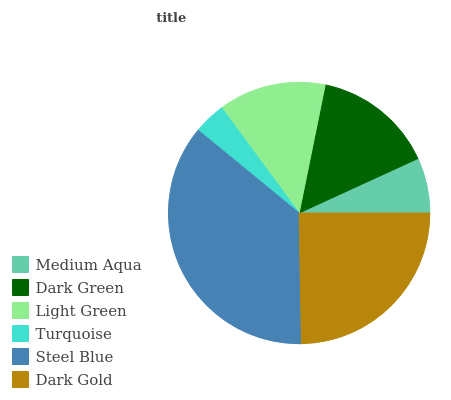Is Turquoise the minimum?
Answer yes or no. Yes. Is Steel Blue the maximum?
Answer yes or no. Yes. Is Dark Green the minimum?
Answer yes or no. No. Is Dark Green the maximum?
Answer yes or no. No. Is Dark Green greater than Medium Aqua?
Answer yes or no. Yes. Is Medium Aqua less than Dark Green?
Answer yes or no. Yes. Is Medium Aqua greater than Dark Green?
Answer yes or no. No. Is Dark Green less than Medium Aqua?
Answer yes or no. No. Is Dark Green the high median?
Answer yes or no. Yes. Is Light Green the low median?
Answer yes or no. Yes. Is Steel Blue the high median?
Answer yes or no. No. Is Dark Gold the low median?
Answer yes or no. No. 